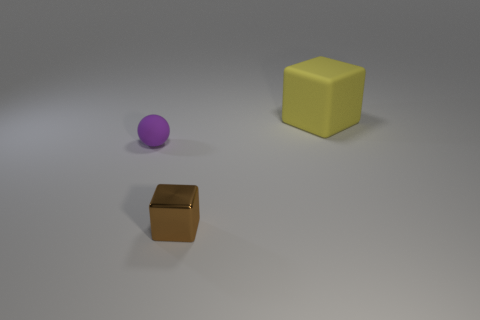Add 2 cylinders. How many objects exist? 5 Subtract all blocks. How many objects are left? 1 Add 2 small cyan rubber cubes. How many small cyan rubber cubes exist? 2 Subtract 0 blue balls. How many objects are left? 3 Subtract all tiny cyan rubber cubes. Subtract all cubes. How many objects are left? 1 Add 3 brown shiny objects. How many brown shiny objects are left? 4 